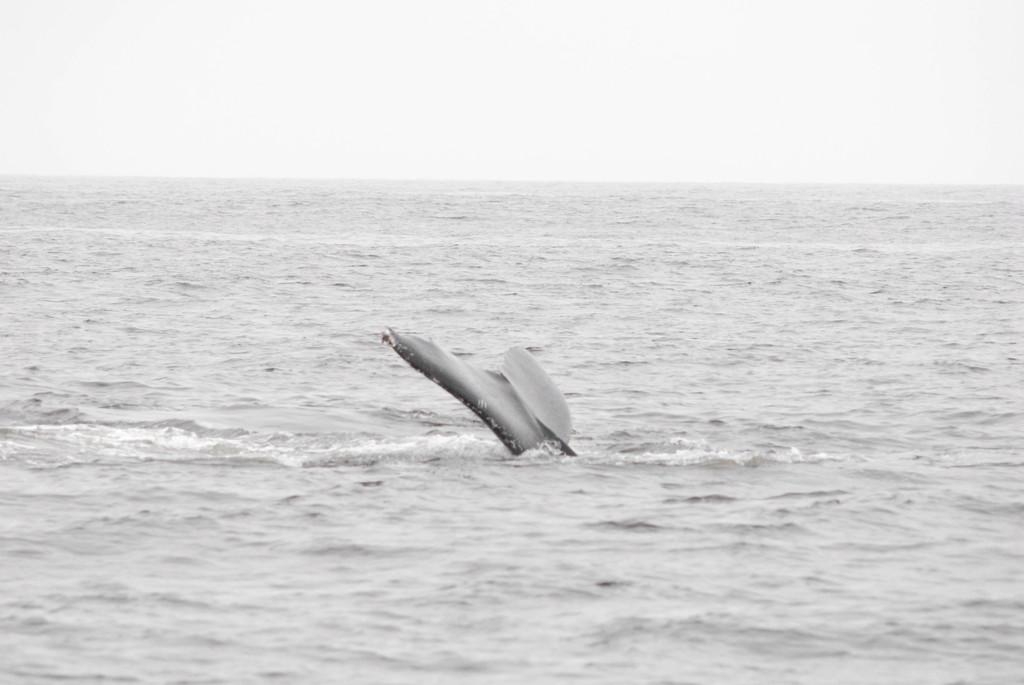What type of body of water is present in the image? There is a sea in the image. What can be seen in the center of the image? A fishtail is visible in the center of the image. What type of utensil is the monkey holding in the image? There is no monkey or utensil present in the image. How does the toothbrush help the fish in the image? There is no toothbrush or fish present in the image. 